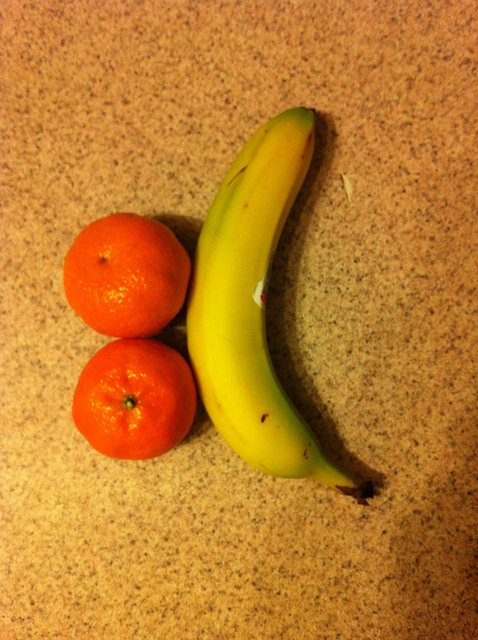Describe the objects in this image and their specific colors. I can see banana in tan, orange, olive, and gold tones, orange in tan, red, maroon, and orange tones, and orange in tan, red, maroon, and orange tones in this image. 